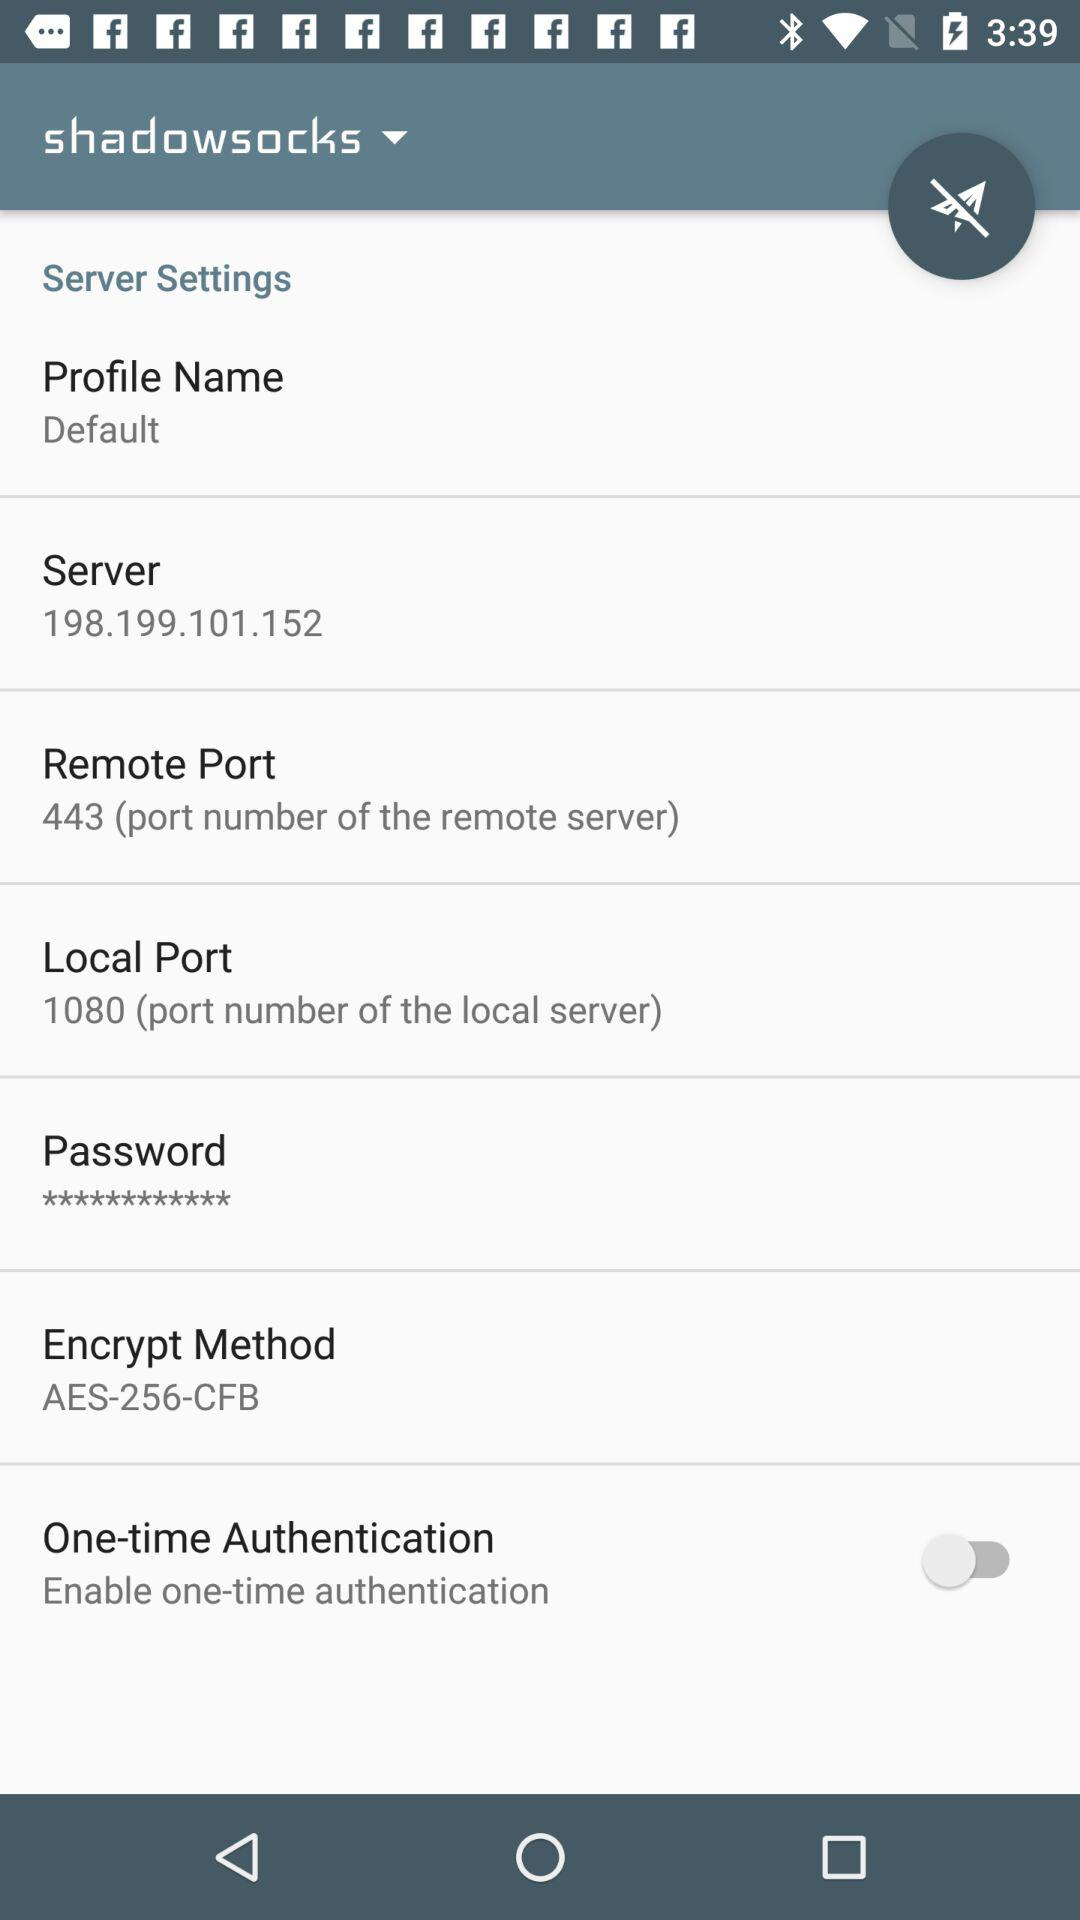What is the port number of the local server?
Answer the question using a single word or phrase. 1080 